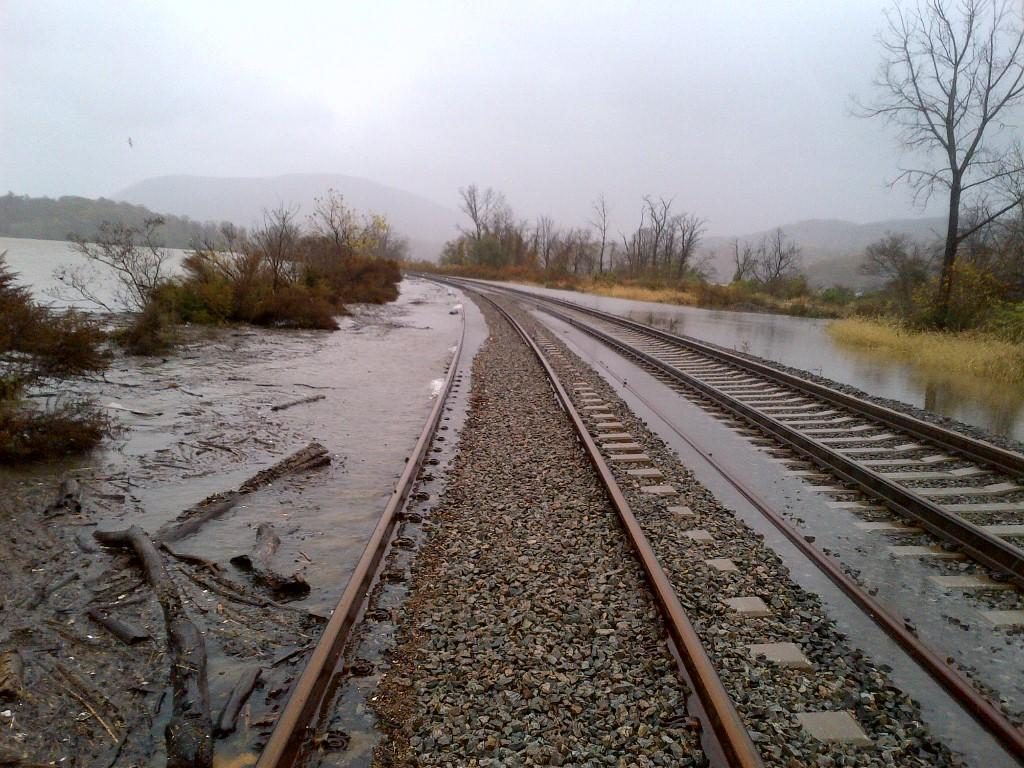What can be seen running parallel to each other in the image? There are two tracks in the image. What natural element is visible in the image? There is water visible in the image. What type of vegetation is present on either side of the tracks? There are trees on either side of the tracks. What type of landscape can be seen in the background of the image? There are mountains in the background of the image. How many cows are grazing on the stem in the image? There are no cows or stems present in the image. What type of horses can be seen running alongside the tracks in the image? There are no horses present in the image; only the tracks, water, trees, and mountains are visible. 